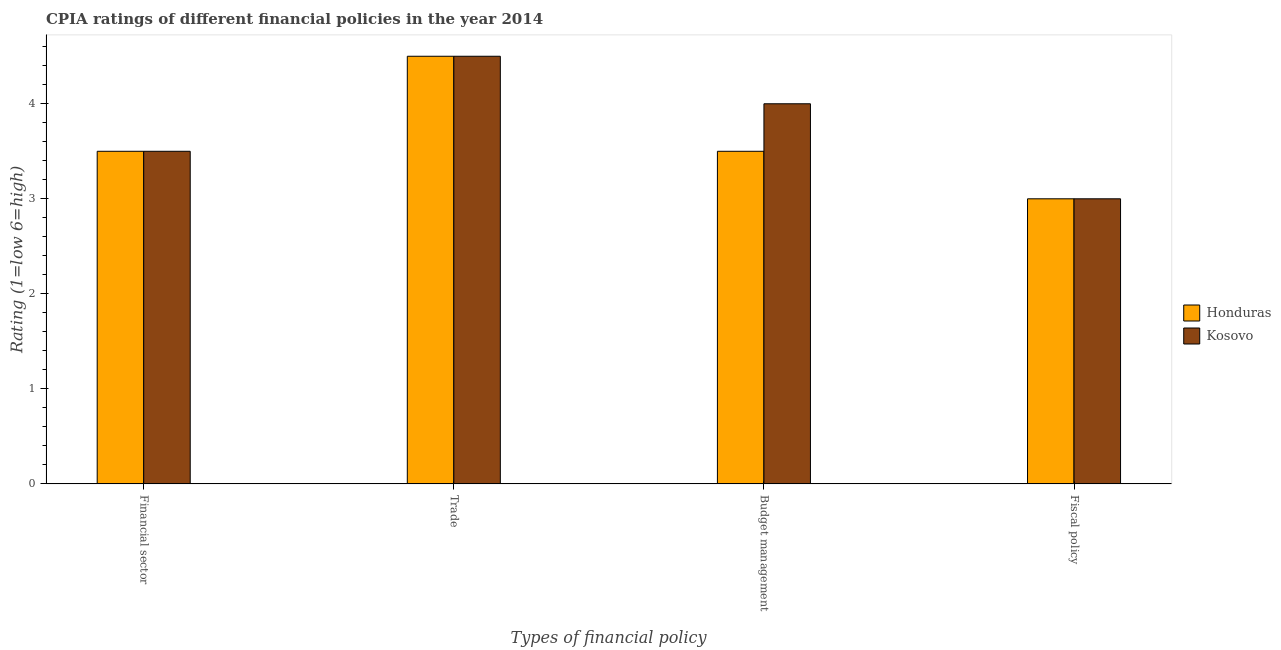How many groups of bars are there?
Make the answer very short. 4. Are the number of bars per tick equal to the number of legend labels?
Offer a terse response. Yes. How many bars are there on the 1st tick from the right?
Give a very brief answer. 2. What is the label of the 2nd group of bars from the left?
Ensure brevity in your answer.  Trade. Across all countries, what is the maximum cpia rating of trade?
Your response must be concise. 4.5. In which country was the cpia rating of trade maximum?
Your answer should be compact. Honduras. In which country was the cpia rating of fiscal policy minimum?
Give a very brief answer. Honduras. What is the total cpia rating of trade in the graph?
Offer a very short reply. 9. What is the difference between the cpia rating of budget management in Kosovo and the cpia rating of financial sector in Honduras?
Provide a short and direct response. 0.5. In how many countries, is the cpia rating of fiscal policy greater than 3 ?
Your response must be concise. 0. Is the difference between the cpia rating of trade in Kosovo and Honduras greater than the difference between the cpia rating of budget management in Kosovo and Honduras?
Your response must be concise. No. Is the sum of the cpia rating of fiscal policy in Kosovo and Honduras greater than the maximum cpia rating of financial sector across all countries?
Provide a short and direct response. Yes. Is it the case that in every country, the sum of the cpia rating of trade and cpia rating of financial sector is greater than the sum of cpia rating of budget management and cpia rating of fiscal policy?
Keep it short and to the point. Yes. What does the 1st bar from the left in Budget management represents?
Offer a terse response. Honduras. What does the 1st bar from the right in Budget management represents?
Your answer should be very brief. Kosovo. Is it the case that in every country, the sum of the cpia rating of financial sector and cpia rating of trade is greater than the cpia rating of budget management?
Offer a terse response. Yes. How many countries are there in the graph?
Make the answer very short. 2. How many legend labels are there?
Make the answer very short. 2. How are the legend labels stacked?
Your answer should be compact. Vertical. What is the title of the graph?
Make the answer very short. CPIA ratings of different financial policies in the year 2014. Does "Belize" appear as one of the legend labels in the graph?
Offer a terse response. No. What is the label or title of the X-axis?
Provide a succinct answer. Types of financial policy. What is the label or title of the Y-axis?
Your response must be concise. Rating (1=low 6=high). What is the Rating (1=low 6=high) of Kosovo in Financial sector?
Your response must be concise. 3.5. What is the Rating (1=low 6=high) of Kosovo in Trade?
Offer a terse response. 4.5. What is the Rating (1=low 6=high) in Honduras in Fiscal policy?
Make the answer very short. 3. Across all Types of financial policy, what is the maximum Rating (1=low 6=high) in Kosovo?
Your answer should be compact. 4.5. Across all Types of financial policy, what is the minimum Rating (1=low 6=high) of Honduras?
Offer a very short reply. 3. Across all Types of financial policy, what is the minimum Rating (1=low 6=high) in Kosovo?
Give a very brief answer. 3. What is the total Rating (1=low 6=high) in Honduras in the graph?
Offer a very short reply. 14.5. What is the difference between the Rating (1=low 6=high) in Kosovo in Financial sector and that in Budget management?
Keep it short and to the point. -0.5. What is the difference between the Rating (1=low 6=high) of Honduras in Financial sector and that in Fiscal policy?
Your response must be concise. 0.5. What is the difference between the Rating (1=low 6=high) in Honduras in Trade and that in Budget management?
Keep it short and to the point. 1. What is the difference between the Rating (1=low 6=high) of Honduras in Trade and that in Fiscal policy?
Make the answer very short. 1.5. What is the difference between the Rating (1=low 6=high) in Honduras in Budget management and that in Fiscal policy?
Give a very brief answer. 0.5. What is the difference between the Rating (1=low 6=high) in Honduras in Financial sector and the Rating (1=low 6=high) in Kosovo in Fiscal policy?
Offer a very short reply. 0.5. What is the difference between the Rating (1=low 6=high) in Honduras in Trade and the Rating (1=low 6=high) in Kosovo in Budget management?
Your answer should be compact. 0.5. What is the difference between the Rating (1=low 6=high) in Honduras in Budget management and the Rating (1=low 6=high) in Kosovo in Fiscal policy?
Your answer should be compact. 0.5. What is the average Rating (1=low 6=high) of Honduras per Types of financial policy?
Make the answer very short. 3.62. What is the average Rating (1=low 6=high) of Kosovo per Types of financial policy?
Ensure brevity in your answer.  3.75. What is the difference between the Rating (1=low 6=high) in Honduras and Rating (1=low 6=high) in Kosovo in Financial sector?
Ensure brevity in your answer.  0. What is the difference between the Rating (1=low 6=high) of Honduras and Rating (1=low 6=high) of Kosovo in Trade?
Offer a very short reply. 0. What is the difference between the Rating (1=low 6=high) of Honduras and Rating (1=low 6=high) of Kosovo in Fiscal policy?
Keep it short and to the point. 0. What is the ratio of the Rating (1=low 6=high) of Kosovo in Financial sector to that in Trade?
Your answer should be very brief. 0.78. What is the ratio of the Rating (1=low 6=high) of Honduras in Financial sector to that in Budget management?
Your answer should be compact. 1. What is the ratio of the Rating (1=low 6=high) in Kosovo in Financial sector to that in Budget management?
Your answer should be very brief. 0.88. What is the ratio of the Rating (1=low 6=high) of Honduras in Financial sector to that in Fiscal policy?
Your answer should be very brief. 1.17. What is the ratio of the Rating (1=low 6=high) in Honduras in Trade to that in Budget management?
Provide a short and direct response. 1.29. What is the ratio of the Rating (1=low 6=high) in Honduras in Trade to that in Fiscal policy?
Give a very brief answer. 1.5. What is the ratio of the Rating (1=low 6=high) in Kosovo in Trade to that in Fiscal policy?
Give a very brief answer. 1.5. What is the ratio of the Rating (1=low 6=high) in Kosovo in Budget management to that in Fiscal policy?
Offer a terse response. 1.33. What is the difference between the highest and the lowest Rating (1=low 6=high) in Honduras?
Offer a very short reply. 1.5. 